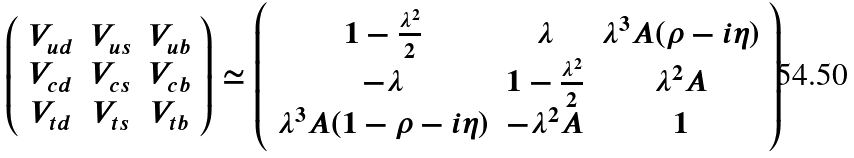Convert formula to latex. <formula><loc_0><loc_0><loc_500><loc_500>\left ( \begin{array} { c c c } V _ { u d } & V _ { u s } & V _ { u b } \\ V _ { c d } & V _ { c s } & V _ { c b } \\ V _ { t d } & V _ { t s } & V _ { t b } \end{array} \right ) \simeq \left ( \begin{array} { c c c } 1 - \frac { \lambda ^ { 2 } } { 2 } & \lambda & \lambda ^ { 3 } A ( \rho - i \eta ) \\ - \lambda & 1 - \frac { \lambda ^ { 2 } } { 2 } & \lambda ^ { 2 } A \\ \lambda ^ { 3 } A ( 1 - \rho - i \eta ) & - \lambda ^ { 2 } A & 1 \end{array} \right )</formula> 